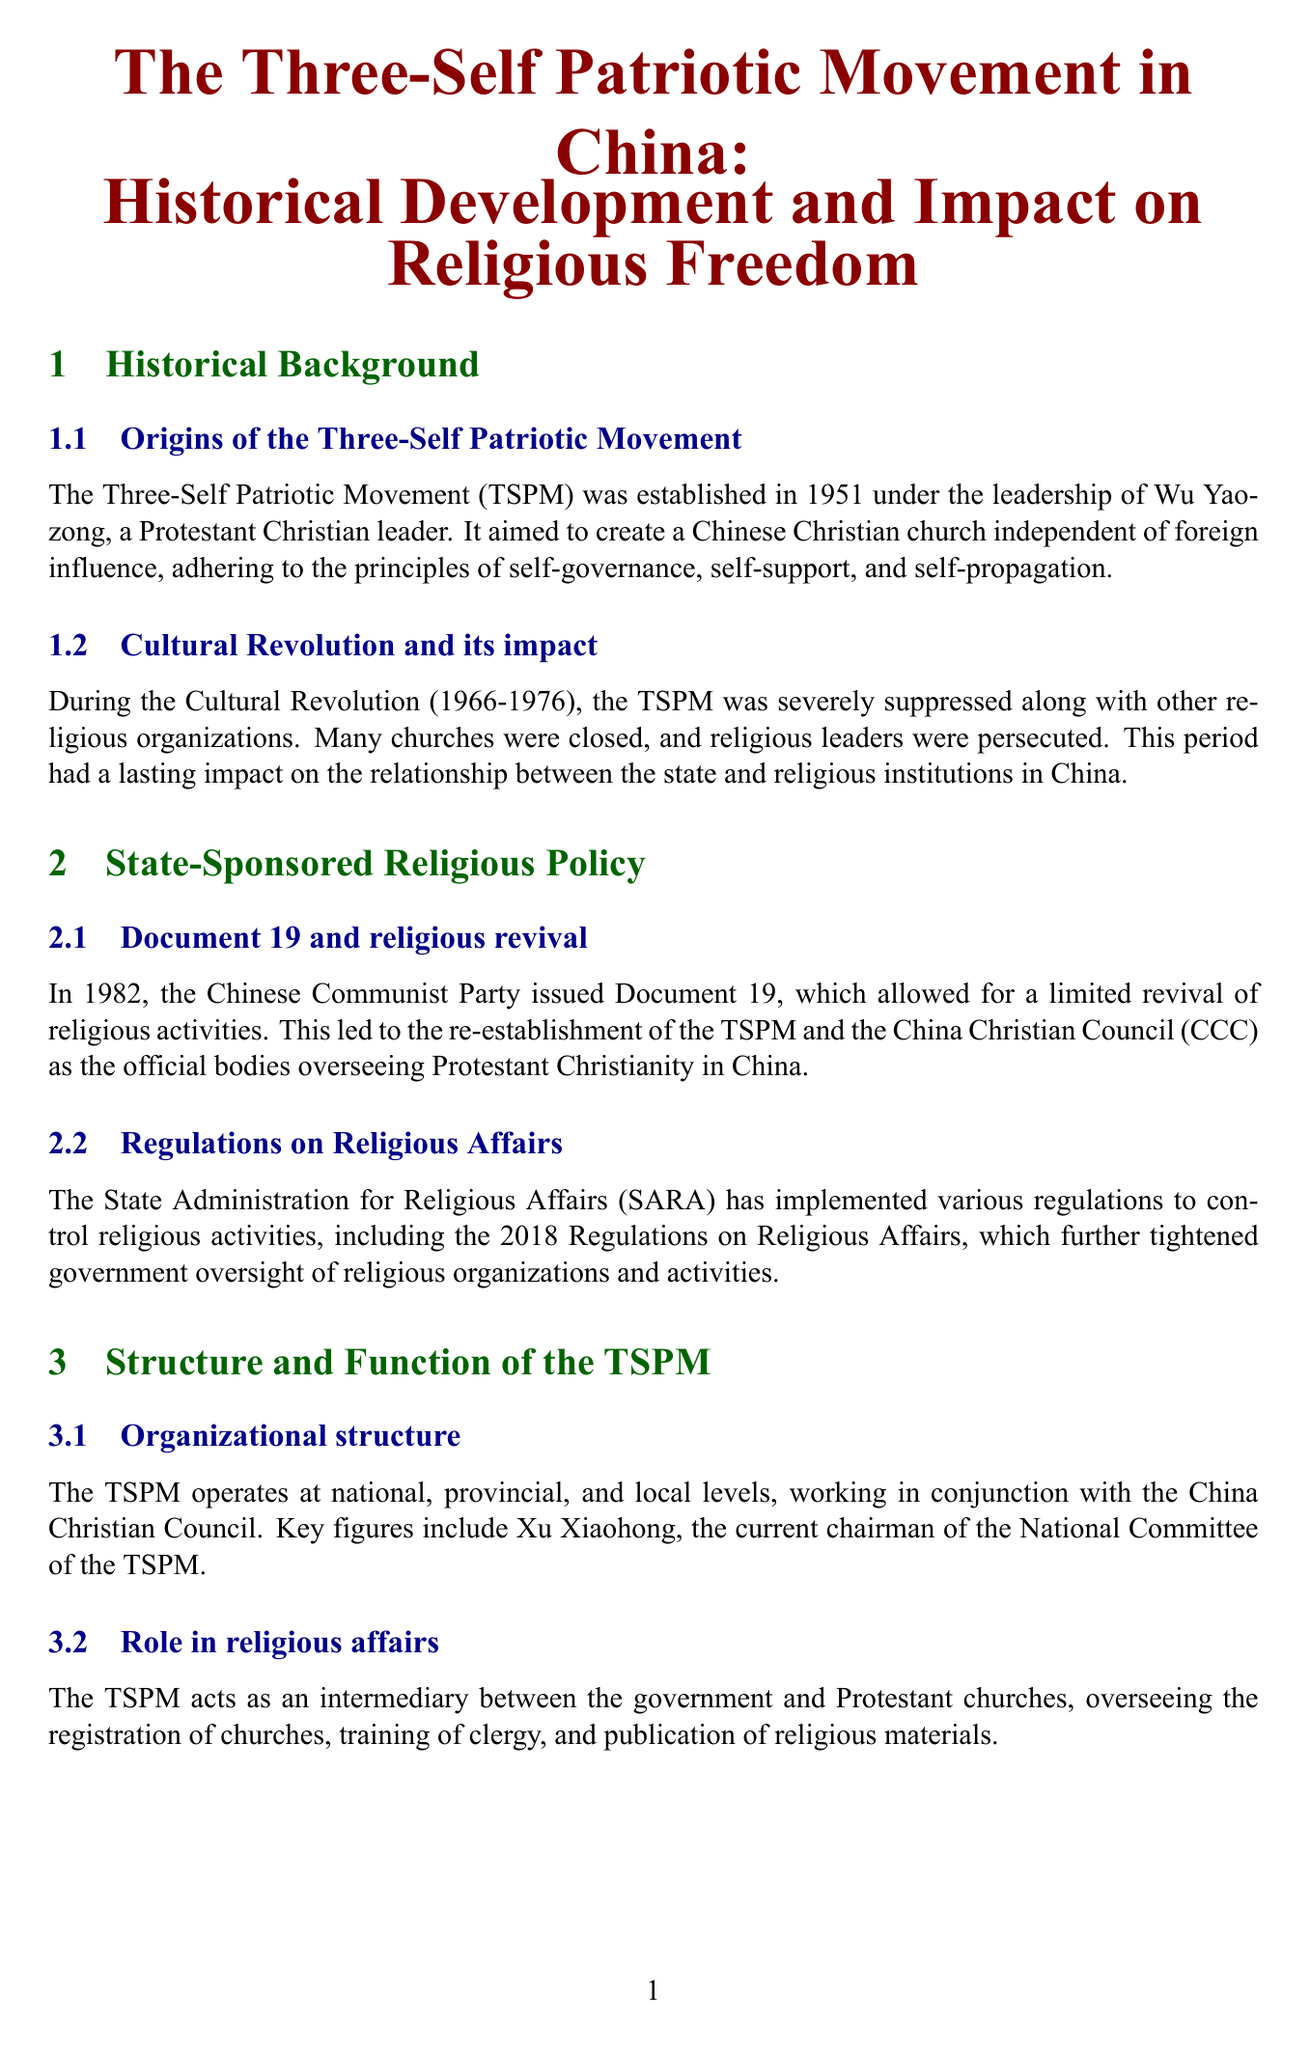what year was the Three-Self Patriotic Movement established? The TSPM was established in 1951.
Answer: 1951 who was the leader of the Three-Self Patriotic Movement when it was founded? Wu Yaozong was a Protestant Christian leader who established the TSPM.
Answer: Wu Yaozong what document allowed for a limited revival of religious activities in 1982? Document 19 is mentioned as allowing a limited revival of religious activities.
Answer: Document 19 which event led to the severe suppression of the TSPM? The Cultural Revolution (1966-1976) led to the severe suppression of the TSPM.
Answer: Cultural Revolution what role does the TSPM play in relation to Protestant churches? The TSPM acts as an intermediary between the government and Protestant churches.
Answer: intermediary what are the principles of the Three Selfs promoted by TSPM? The principles are self-governance, self-support, and self-propagation.
Answer: self-governance, self-support, self-propagation what technology has raised concerns about privacy in churches? Facial recognition cameras in churches have raised concerns about privacy.
Answer: Facial recognition cameras who are two scholars mentioned in the document contributing to the debate on state-religion relations? Yang Fenggang and Carsten Vala are the scholars mentioned.
Answer: Yang Fenggang and Carsten Vala what does the term 'sinicization' refer to in the context of TSPM? Sinicization refers to the push for a version of Christianity that aligns with socialist values and Chinese culture.
Answer: alignment with socialist values and Chinese culture 